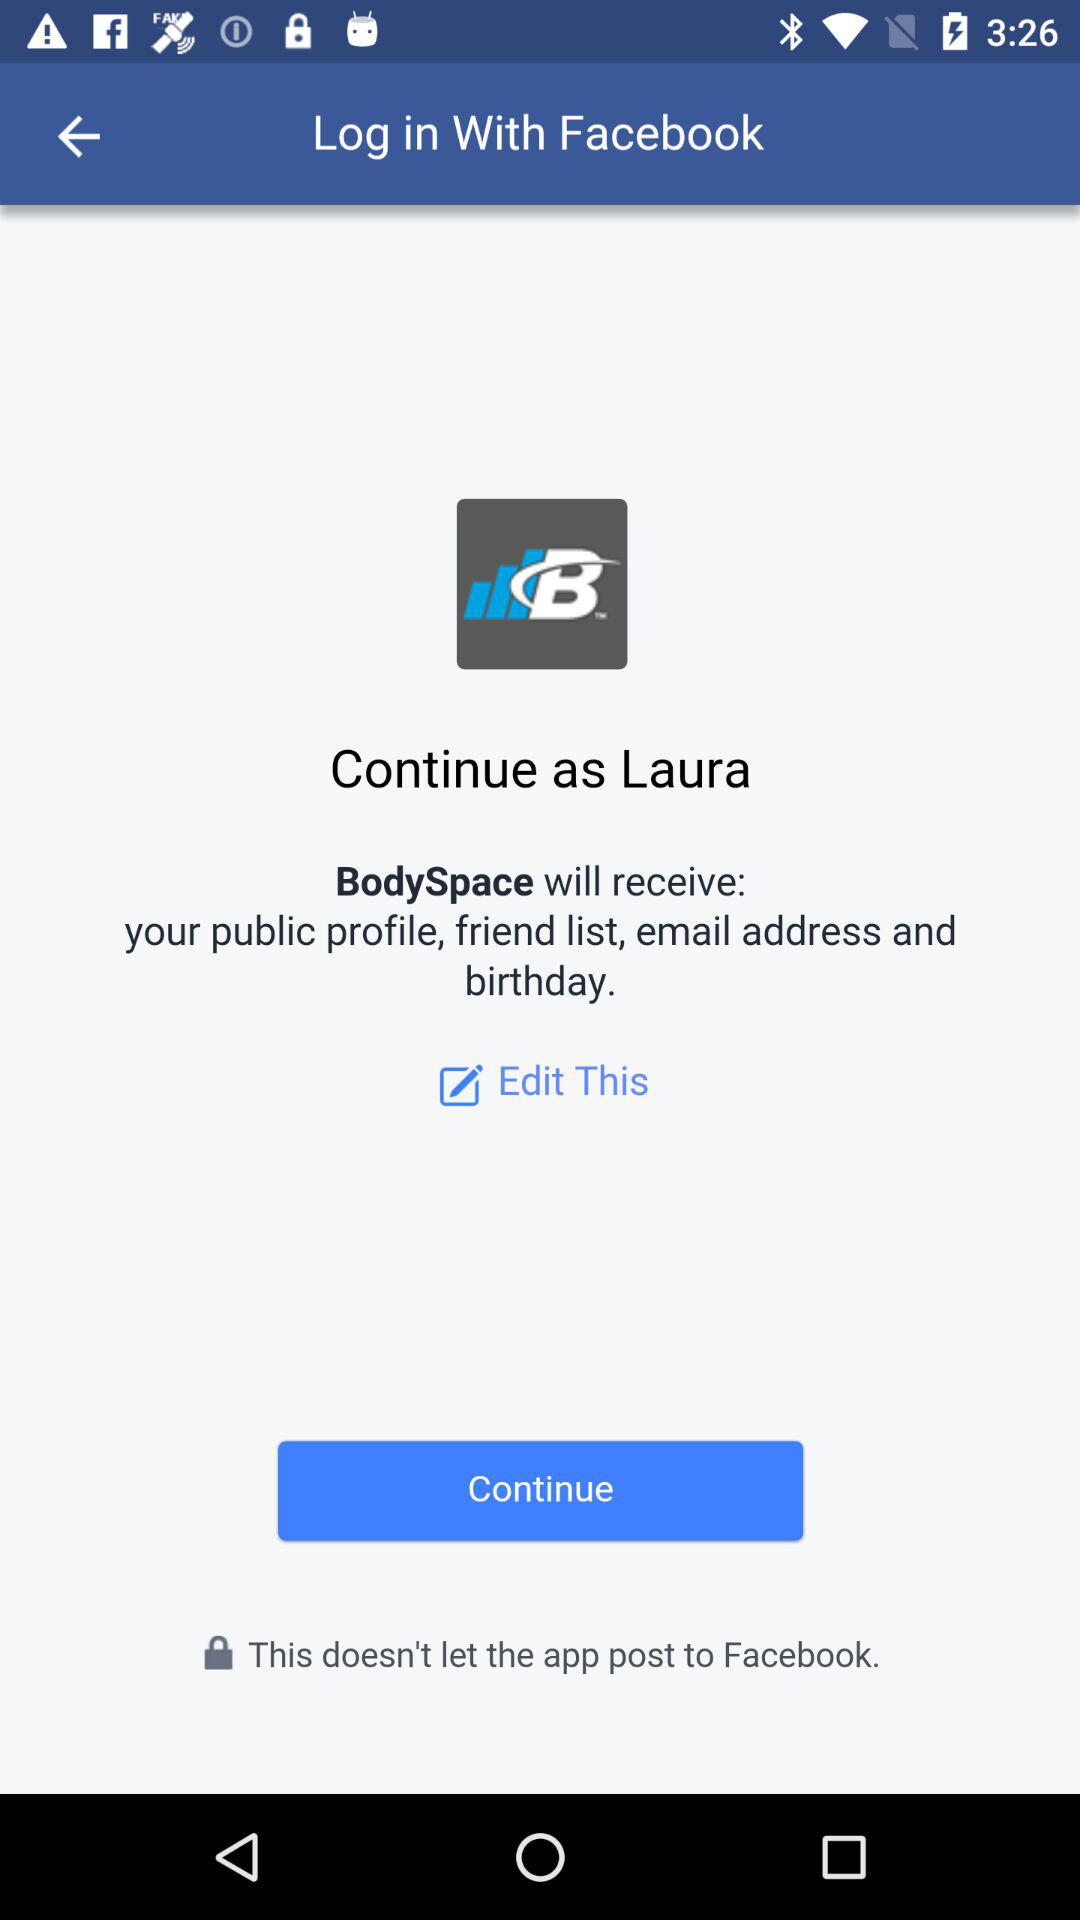By what user name can the application be continued? The user name is Laura. 